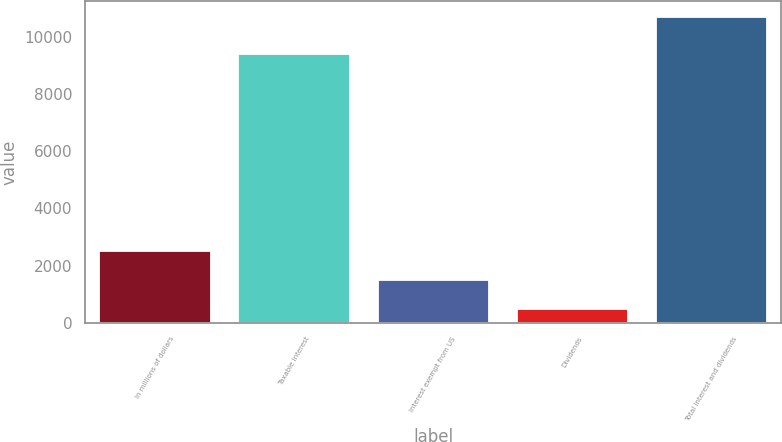Convert chart to OTSL. <chart><loc_0><loc_0><loc_500><loc_500><bar_chart><fcel>In millions of dollars<fcel>Taxable interest<fcel>Interest exempt from US<fcel>Dividends<fcel>Total interest and dividends<nl><fcel>2523.6<fcel>9407<fcel>1499.3<fcel>475<fcel>10718<nl></chart> 